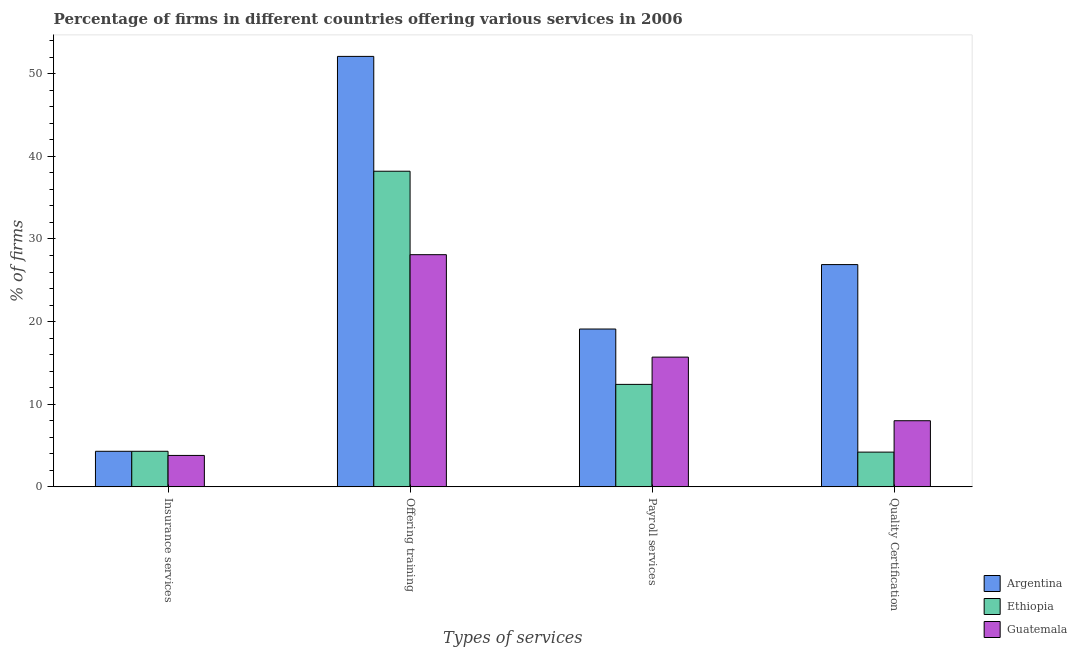How many different coloured bars are there?
Your answer should be compact. 3. How many groups of bars are there?
Your answer should be very brief. 4. How many bars are there on the 3rd tick from the left?
Ensure brevity in your answer.  3. How many bars are there on the 1st tick from the right?
Your response must be concise. 3. What is the label of the 2nd group of bars from the left?
Give a very brief answer. Offering training. What is the percentage of firms offering quality certification in Guatemala?
Offer a very short reply. 8. Across all countries, what is the minimum percentage of firms offering insurance services?
Give a very brief answer. 3.8. In which country was the percentage of firms offering insurance services maximum?
Provide a short and direct response. Argentina. In which country was the percentage of firms offering quality certification minimum?
Provide a short and direct response. Ethiopia. What is the total percentage of firms offering training in the graph?
Your response must be concise. 118.4. What is the difference between the percentage of firms offering training in Argentina and the percentage of firms offering insurance services in Ethiopia?
Give a very brief answer. 47.8. What is the average percentage of firms offering quality certification per country?
Provide a succinct answer. 13.03. What is the difference between the percentage of firms offering quality certification and percentage of firms offering insurance services in Guatemala?
Provide a succinct answer. 4.2. In how many countries, is the percentage of firms offering payroll services greater than 14 %?
Provide a succinct answer. 2. What is the ratio of the percentage of firms offering quality certification in Guatemala to that in Argentina?
Provide a short and direct response. 0.3. Is the percentage of firms offering insurance services in Guatemala less than that in Argentina?
Ensure brevity in your answer.  Yes. What is the difference between the highest and the second highest percentage of firms offering insurance services?
Keep it short and to the point. 0. What is the difference between the highest and the lowest percentage of firms offering quality certification?
Provide a short and direct response. 22.7. In how many countries, is the percentage of firms offering training greater than the average percentage of firms offering training taken over all countries?
Your answer should be very brief. 1. Is the sum of the percentage of firms offering training in Guatemala and Ethiopia greater than the maximum percentage of firms offering payroll services across all countries?
Offer a very short reply. Yes. Is it the case that in every country, the sum of the percentage of firms offering training and percentage of firms offering insurance services is greater than the sum of percentage of firms offering payroll services and percentage of firms offering quality certification?
Give a very brief answer. No. What does the 3rd bar from the left in Payroll services represents?
Keep it short and to the point. Guatemala. What does the 1st bar from the right in Offering training represents?
Provide a short and direct response. Guatemala. How many countries are there in the graph?
Provide a succinct answer. 3. What is the difference between two consecutive major ticks on the Y-axis?
Keep it short and to the point. 10. How many legend labels are there?
Your answer should be compact. 3. What is the title of the graph?
Ensure brevity in your answer.  Percentage of firms in different countries offering various services in 2006. Does "Lithuania" appear as one of the legend labels in the graph?
Your response must be concise. No. What is the label or title of the X-axis?
Provide a succinct answer. Types of services. What is the label or title of the Y-axis?
Provide a short and direct response. % of firms. What is the % of firms in Argentina in Insurance services?
Your answer should be very brief. 4.3. What is the % of firms in Guatemala in Insurance services?
Your answer should be very brief. 3.8. What is the % of firms of Argentina in Offering training?
Make the answer very short. 52.1. What is the % of firms of Ethiopia in Offering training?
Provide a short and direct response. 38.2. What is the % of firms of Guatemala in Offering training?
Your response must be concise. 28.1. What is the % of firms in Argentina in Payroll services?
Ensure brevity in your answer.  19.1. What is the % of firms in Ethiopia in Payroll services?
Give a very brief answer. 12.4. What is the % of firms of Guatemala in Payroll services?
Your answer should be compact. 15.7. What is the % of firms in Argentina in Quality Certification?
Give a very brief answer. 26.9. Across all Types of services, what is the maximum % of firms of Argentina?
Offer a terse response. 52.1. Across all Types of services, what is the maximum % of firms in Ethiopia?
Your answer should be very brief. 38.2. Across all Types of services, what is the maximum % of firms of Guatemala?
Your answer should be compact. 28.1. Across all Types of services, what is the minimum % of firms in Argentina?
Provide a short and direct response. 4.3. Across all Types of services, what is the minimum % of firms of Ethiopia?
Your answer should be compact. 4.2. Across all Types of services, what is the minimum % of firms in Guatemala?
Make the answer very short. 3.8. What is the total % of firms in Argentina in the graph?
Keep it short and to the point. 102.4. What is the total % of firms of Ethiopia in the graph?
Ensure brevity in your answer.  59.1. What is the total % of firms in Guatemala in the graph?
Make the answer very short. 55.6. What is the difference between the % of firms of Argentina in Insurance services and that in Offering training?
Offer a terse response. -47.8. What is the difference between the % of firms in Ethiopia in Insurance services and that in Offering training?
Keep it short and to the point. -33.9. What is the difference between the % of firms of Guatemala in Insurance services and that in Offering training?
Offer a terse response. -24.3. What is the difference between the % of firms of Argentina in Insurance services and that in Payroll services?
Your answer should be very brief. -14.8. What is the difference between the % of firms in Ethiopia in Insurance services and that in Payroll services?
Give a very brief answer. -8.1. What is the difference between the % of firms of Guatemala in Insurance services and that in Payroll services?
Your answer should be compact. -11.9. What is the difference between the % of firms in Argentina in Insurance services and that in Quality Certification?
Your answer should be compact. -22.6. What is the difference between the % of firms in Ethiopia in Insurance services and that in Quality Certification?
Your answer should be very brief. 0.1. What is the difference between the % of firms in Argentina in Offering training and that in Payroll services?
Provide a short and direct response. 33. What is the difference between the % of firms of Ethiopia in Offering training and that in Payroll services?
Your answer should be compact. 25.8. What is the difference between the % of firms in Argentina in Offering training and that in Quality Certification?
Your answer should be very brief. 25.2. What is the difference between the % of firms of Guatemala in Offering training and that in Quality Certification?
Make the answer very short. 20.1. What is the difference between the % of firms in Argentina in Payroll services and that in Quality Certification?
Your answer should be compact. -7.8. What is the difference between the % of firms in Guatemala in Payroll services and that in Quality Certification?
Ensure brevity in your answer.  7.7. What is the difference between the % of firms of Argentina in Insurance services and the % of firms of Ethiopia in Offering training?
Your answer should be very brief. -33.9. What is the difference between the % of firms in Argentina in Insurance services and the % of firms in Guatemala in Offering training?
Keep it short and to the point. -23.8. What is the difference between the % of firms in Ethiopia in Insurance services and the % of firms in Guatemala in Offering training?
Keep it short and to the point. -23.8. What is the difference between the % of firms of Argentina in Insurance services and the % of firms of Ethiopia in Payroll services?
Provide a succinct answer. -8.1. What is the difference between the % of firms of Argentina in Insurance services and the % of firms of Guatemala in Payroll services?
Your answer should be compact. -11.4. What is the difference between the % of firms of Ethiopia in Insurance services and the % of firms of Guatemala in Payroll services?
Provide a short and direct response. -11.4. What is the difference between the % of firms of Ethiopia in Insurance services and the % of firms of Guatemala in Quality Certification?
Give a very brief answer. -3.7. What is the difference between the % of firms of Argentina in Offering training and the % of firms of Ethiopia in Payroll services?
Ensure brevity in your answer.  39.7. What is the difference between the % of firms of Argentina in Offering training and the % of firms of Guatemala in Payroll services?
Your response must be concise. 36.4. What is the difference between the % of firms in Ethiopia in Offering training and the % of firms in Guatemala in Payroll services?
Your answer should be very brief. 22.5. What is the difference between the % of firms of Argentina in Offering training and the % of firms of Ethiopia in Quality Certification?
Offer a very short reply. 47.9. What is the difference between the % of firms in Argentina in Offering training and the % of firms in Guatemala in Quality Certification?
Keep it short and to the point. 44.1. What is the difference between the % of firms in Ethiopia in Offering training and the % of firms in Guatemala in Quality Certification?
Ensure brevity in your answer.  30.2. What is the difference between the % of firms of Argentina in Payroll services and the % of firms of Ethiopia in Quality Certification?
Give a very brief answer. 14.9. What is the difference between the % of firms of Argentina in Payroll services and the % of firms of Guatemala in Quality Certification?
Your response must be concise. 11.1. What is the difference between the % of firms of Ethiopia in Payroll services and the % of firms of Guatemala in Quality Certification?
Provide a succinct answer. 4.4. What is the average % of firms of Argentina per Types of services?
Your answer should be very brief. 25.6. What is the average % of firms of Ethiopia per Types of services?
Your answer should be compact. 14.78. What is the difference between the % of firms in Argentina and % of firms in Guatemala in Offering training?
Your answer should be very brief. 24. What is the difference between the % of firms in Ethiopia and % of firms in Guatemala in Offering training?
Offer a very short reply. 10.1. What is the difference between the % of firms in Argentina and % of firms in Ethiopia in Payroll services?
Provide a succinct answer. 6.7. What is the difference between the % of firms in Argentina and % of firms in Guatemala in Payroll services?
Your response must be concise. 3.4. What is the difference between the % of firms in Ethiopia and % of firms in Guatemala in Payroll services?
Provide a short and direct response. -3.3. What is the difference between the % of firms in Argentina and % of firms in Ethiopia in Quality Certification?
Your answer should be very brief. 22.7. What is the ratio of the % of firms in Argentina in Insurance services to that in Offering training?
Ensure brevity in your answer.  0.08. What is the ratio of the % of firms of Ethiopia in Insurance services to that in Offering training?
Provide a short and direct response. 0.11. What is the ratio of the % of firms of Guatemala in Insurance services to that in Offering training?
Offer a very short reply. 0.14. What is the ratio of the % of firms in Argentina in Insurance services to that in Payroll services?
Offer a terse response. 0.23. What is the ratio of the % of firms of Ethiopia in Insurance services to that in Payroll services?
Make the answer very short. 0.35. What is the ratio of the % of firms of Guatemala in Insurance services to that in Payroll services?
Provide a succinct answer. 0.24. What is the ratio of the % of firms of Argentina in Insurance services to that in Quality Certification?
Keep it short and to the point. 0.16. What is the ratio of the % of firms in Ethiopia in Insurance services to that in Quality Certification?
Make the answer very short. 1.02. What is the ratio of the % of firms in Guatemala in Insurance services to that in Quality Certification?
Make the answer very short. 0.47. What is the ratio of the % of firms of Argentina in Offering training to that in Payroll services?
Offer a terse response. 2.73. What is the ratio of the % of firms of Ethiopia in Offering training to that in Payroll services?
Give a very brief answer. 3.08. What is the ratio of the % of firms of Guatemala in Offering training to that in Payroll services?
Make the answer very short. 1.79. What is the ratio of the % of firms in Argentina in Offering training to that in Quality Certification?
Provide a short and direct response. 1.94. What is the ratio of the % of firms in Ethiopia in Offering training to that in Quality Certification?
Your answer should be very brief. 9.1. What is the ratio of the % of firms in Guatemala in Offering training to that in Quality Certification?
Offer a terse response. 3.51. What is the ratio of the % of firms in Argentina in Payroll services to that in Quality Certification?
Make the answer very short. 0.71. What is the ratio of the % of firms of Ethiopia in Payroll services to that in Quality Certification?
Provide a short and direct response. 2.95. What is the ratio of the % of firms in Guatemala in Payroll services to that in Quality Certification?
Provide a succinct answer. 1.96. What is the difference between the highest and the second highest % of firms in Argentina?
Offer a very short reply. 25.2. What is the difference between the highest and the second highest % of firms in Ethiopia?
Give a very brief answer. 25.8. What is the difference between the highest and the lowest % of firms in Argentina?
Keep it short and to the point. 47.8. What is the difference between the highest and the lowest % of firms of Ethiopia?
Give a very brief answer. 34. What is the difference between the highest and the lowest % of firms in Guatemala?
Make the answer very short. 24.3. 